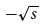Convert formula to latex. <formula><loc_0><loc_0><loc_500><loc_500>- \sqrt { s }</formula> 